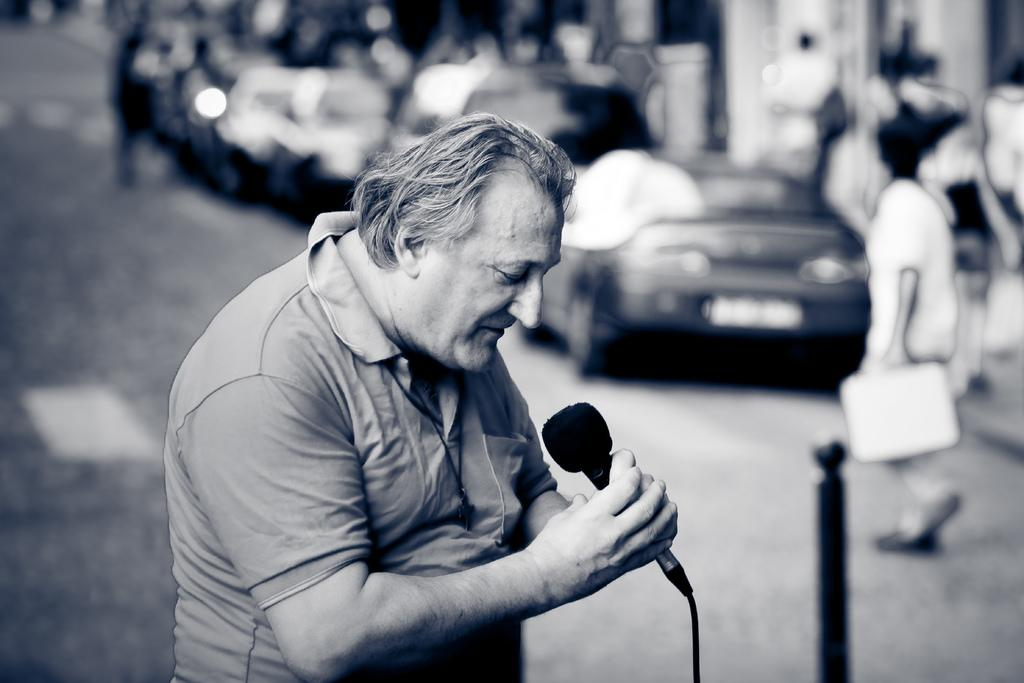What is the main subject of the image? The main subject of the image is a man. What is the man wearing in the image? The man is wearing a T-shirt in the image. What is the man holding in the image? The man is holding a microphone in the image. What can be seen in the background of the image? Cars and persons walking on the road can be seen in the background of the image. How does the snail process information in the image? There is no snail present in the image, so it is not possible to determine how a snail might process information. 